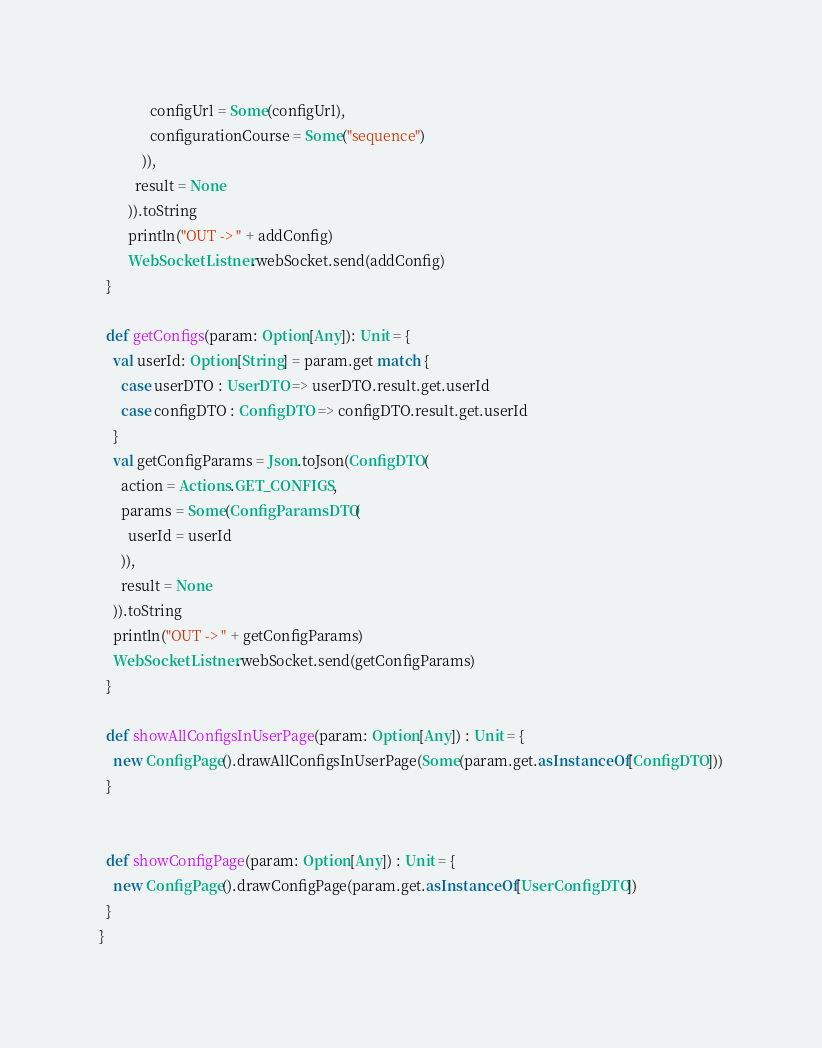Convert code to text. <code><loc_0><loc_0><loc_500><loc_500><_Scala_>              configUrl = Some(configUrl),
              configurationCourse = Some("sequence")
            )),
          result = None
        )).toString
        println("OUT -> " + addConfig)
        WebSocketListner.webSocket.send(addConfig)
  }

  def getConfigs(param: Option[Any]): Unit = {
    val userId: Option[String] = param.get match {
      case userDTO : UserDTO => userDTO.result.get.userId
      case configDTO : ConfigDTO => configDTO.result.get.userId
    }
    val getConfigParams = Json.toJson(ConfigDTO(
      action = Actions.GET_CONFIGS,
      params = Some(ConfigParamsDTO(
        userId = userId
      )),
      result = None
    )).toString
    println("OUT -> " + getConfigParams)
    WebSocketListner.webSocket.send(getConfigParams)
  }

  def showAllConfigsInUserPage(param: Option[Any]) : Unit = {
    new ConfigPage().drawAllConfigsInUserPage(Some(param.get.asInstanceOf[ConfigDTO]))
  }


  def showConfigPage(param: Option[Any]) : Unit = {
    new ConfigPage().drawConfigPage(param.get.asInstanceOf[UserConfigDTO])
  }
}
</code> 